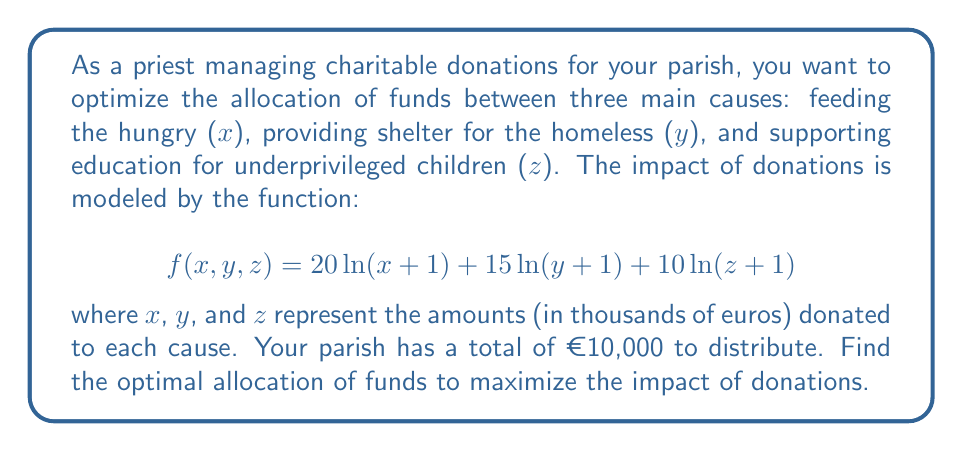Solve this math problem. To solve this optimization problem, we'll use the method of Lagrange multipliers.

1) First, we set up the constraint equation:
   $$g(x,y,z) = x + y + z - 10 = 0$$

2) Now, we form the Lagrangian function:
   $$L(x,y,z,\lambda) = 20\ln(x+1) + 15\ln(y+1) + 10\ln(z+1) - \lambda(x + y + z - 10)$$

3) We take partial derivatives and set them equal to zero:

   $$\frac{\partial L}{\partial x} = \frac{20}{x+1} - \lambda = 0$$
   $$\frac{\partial L}{\partial y} = \frac{15}{y+1} - \lambda = 0$$
   $$\frac{\partial L}{\partial z} = \frac{10}{z+1} - \lambda = 0$$
   $$\frac{\partial L}{\partial \lambda} = x + y + z - 10 = 0$$

4) From these equations, we can deduce:
   $$\frac{20}{x+1} = \frac{15}{y+1} = \frac{10}{z+1} = \lambda$$

5) This implies:
   $$x+1 = \frac{20}{\lambda}, y+1 = \frac{15}{\lambda}, z+1 = \frac{10}{\lambda}$$

6) Substituting these into the constraint equation:
   $$(\frac{20}{\lambda} - 1) + (\frac{15}{\lambda} - 1) + (\frac{10}{\lambda} - 1) = 10$$
   $$\frac{45}{\lambda} - 3 = 10$$
   $$\frac{45}{\lambda} = 13$$
   $$\lambda = \frac{45}{13}$$

7) Now we can solve for x, y, and z:
   $$x = \frac{20}{\lambda} - 1 = \frac{20 \cdot 13}{45} - 1 = \frac{260}{45} - 1 = \frac{215}{45} \approx 4.78$$
   $$y = \frac{15}{\lambda} - 1 = \frac{15 \cdot 13}{45} - 1 = \frac{195}{45} - 1 = \frac{150}{45} \approx 3.33$$
   $$z = \frac{10}{\lambda} - 1 = \frac{10 \cdot 13}{45} - 1 = \frac{130}{45} - 1 = \frac{85}{45} \approx 1.89$$

8) We can verify that these values sum to 10:
   $$\frac{215}{45} + \frac{150}{45} + \frac{85}{45} = \frac{450}{45} = 10$$
Answer: The optimal allocation of funds to maximize the impact of donations is approximately:
- €4,780 for feeding the hungry
- €3,330 for providing shelter for the homeless
- €1,890 for supporting education for underprivileged children 